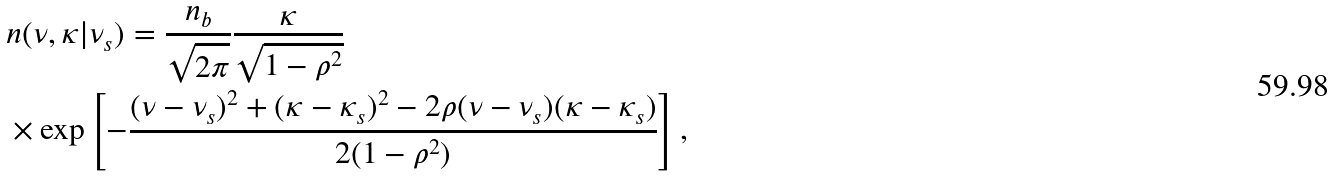Convert formula to latex. <formula><loc_0><loc_0><loc_500><loc_500>& n ( \nu , \kappa | \nu _ { s } ) = \frac { n _ { b } } { \sqrt { 2 \pi } } \frac { \kappa } { \sqrt { 1 - \rho ^ { 2 } } } \\ & \times \exp \left [ - \frac { ( \nu - \nu _ { s } ) ^ { 2 } + ( \kappa - \kappa _ { s } ) ^ { 2 } - 2 \rho ( \nu - \nu _ { s } ) ( \kappa - \kappa _ { s } ) } { 2 ( 1 - \rho ^ { 2 } ) } \right ] ,</formula> 